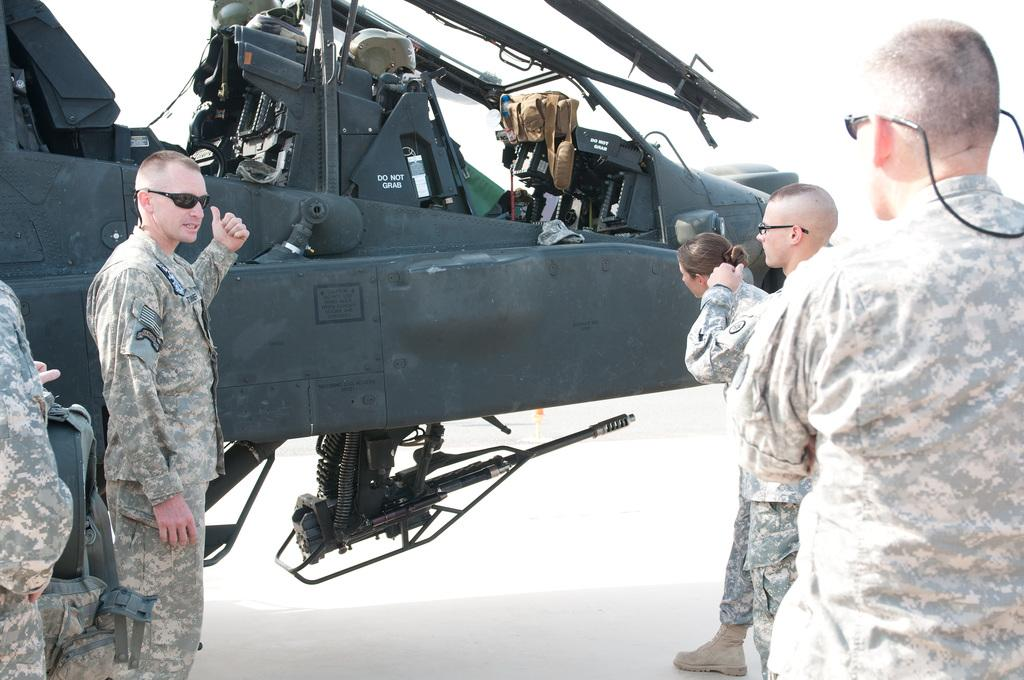What are the people in the image doing? The people in the image are soldiers standing. What else can be seen in the image besides the soldiers? There is an aircraft in the image. How many turkeys are visible in the image? There are no turkeys present in the image. What color are the eyes of the aircraft in the image? The image does not show the eyes of the aircraft, as aircraft do not have eyes. 